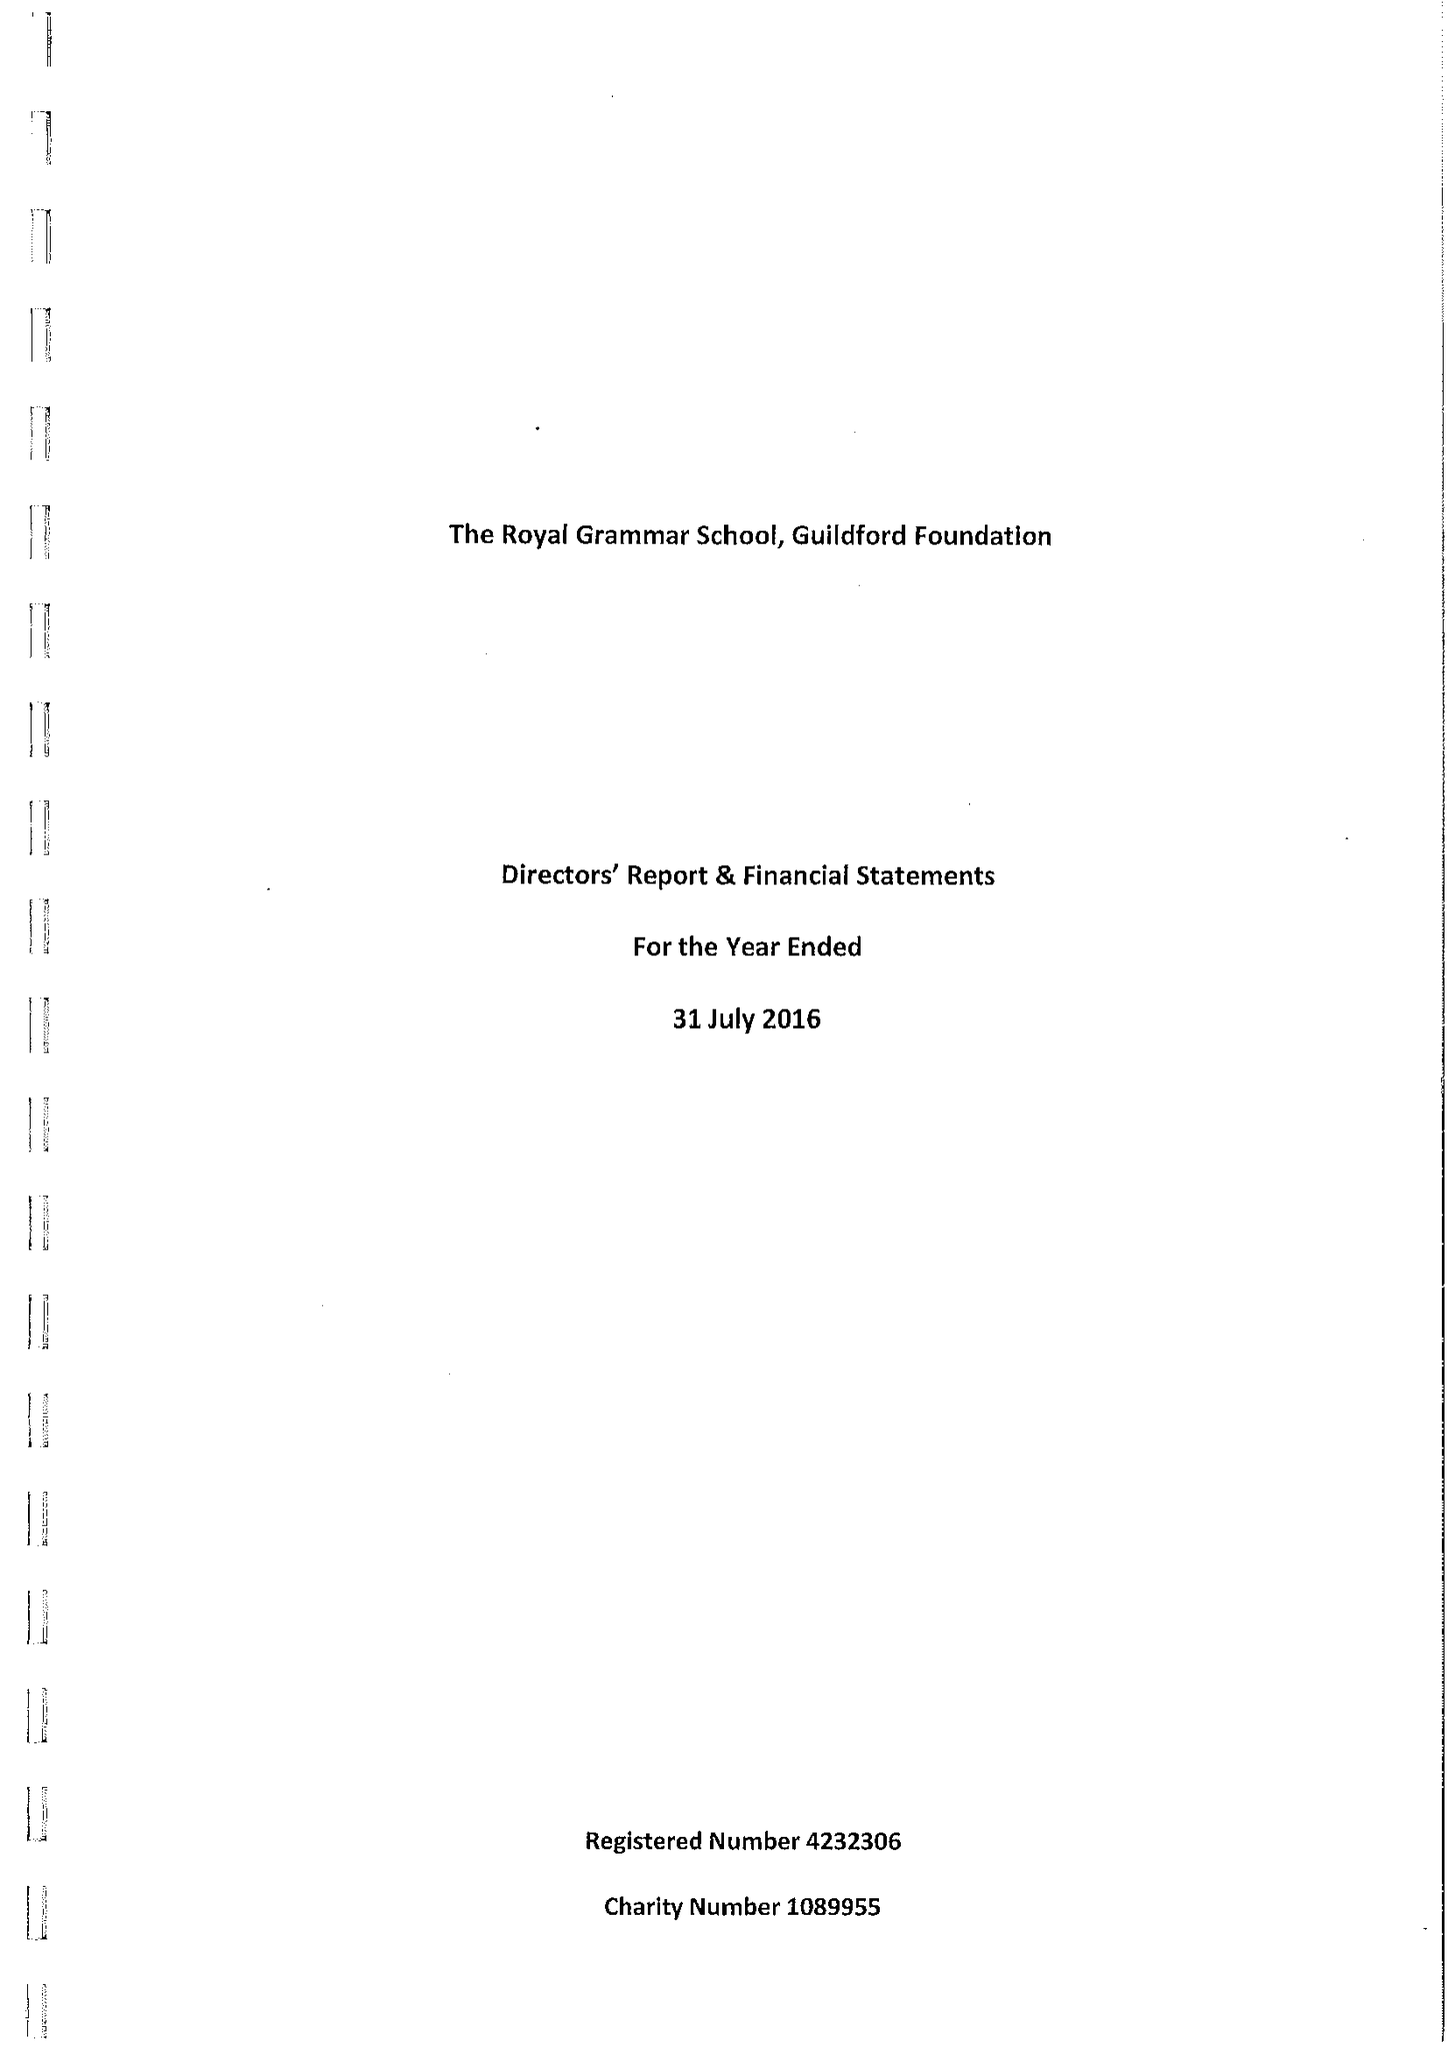What is the value for the spending_annually_in_british_pounds?
Answer the question using a single word or phrase. 173280.00 